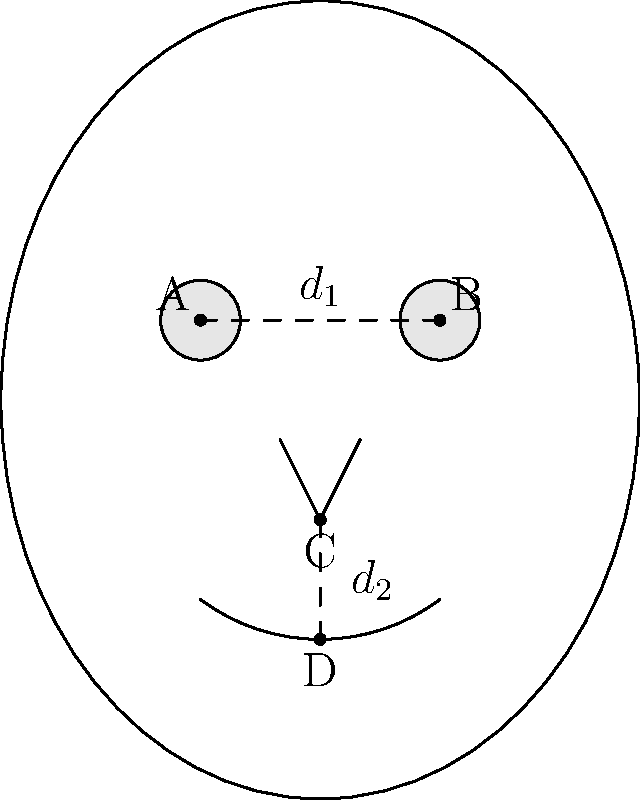In analyzing surveillance footage, you need to quickly estimate facial proportions. Given that the distance between the centers of the eyes (A to B) is $d_1 = 6.3$ cm, and the vertical distance from the tip of the nose to the center of the mouth (C to D) is $d_2 = 4.5$ cm, calculate the ratio $\frac{d_1}{d_2}$ rounded to two decimal places. How might this ratio be useful in facial recognition systems? To solve this problem and understand its relevance to facial recognition, let's follow these steps:

1. Identify the given measurements:
   - Distance between eye centers (A to B): $d_1 = 6.3$ cm
   - Vertical distance from nose tip to mouth center (C to D): $d_2 = 4.5$ cm

2. Calculate the ratio $\frac{d_1}{d_2}$:
   $\frac{d_1}{d_2} = \frac{6.3}{4.5}$

3. Perform the division:
   $\frac{6.3}{4.5} = 1.4$

4. Round to two decimal places:
   1.40

5. Relevance to facial recognition:
   - This ratio represents a proportion of facial features that remains relatively constant across different facial expressions and viewing angles.
   - It can be used as a biometric identifier, helping to match faces even when the overall size of the face in an image varies due to distance from the camera.
   - The consistency of this ratio makes it valuable for comparing faces in different surveillance footage or for matching against a database of known individuals.
   - In intelligence work, such ratios can be crucial for quickly identifying persons of interest in time-sensitive situations, even with partial or low-quality footage.
Answer: 1.40 